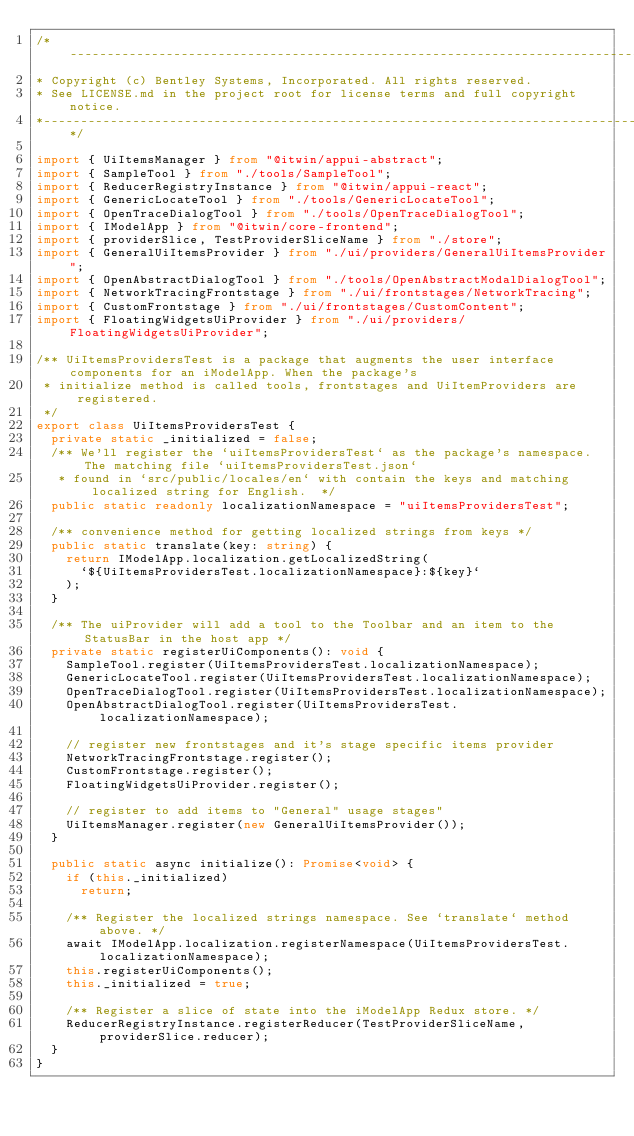<code> <loc_0><loc_0><loc_500><loc_500><_TypeScript_>/*---------------------------------------------------------------------------------------------
* Copyright (c) Bentley Systems, Incorporated. All rights reserved.
* See LICENSE.md in the project root for license terms and full copyright notice.
*--------------------------------------------------------------------------------------------*/

import { UiItemsManager } from "@itwin/appui-abstract";
import { SampleTool } from "./tools/SampleTool";
import { ReducerRegistryInstance } from "@itwin/appui-react";
import { GenericLocateTool } from "./tools/GenericLocateTool";
import { OpenTraceDialogTool } from "./tools/OpenTraceDialogTool";
import { IModelApp } from "@itwin/core-frontend";
import { providerSlice, TestProviderSliceName } from "./store";
import { GeneralUiItemsProvider } from "./ui/providers/GeneralUiItemsProvider";
import { OpenAbstractDialogTool } from "./tools/OpenAbstractModalDialogTool";
import { NetworkTracingFrontstage } from "./ui/frontstages/NetworkTracing";
import { CustomFrontstage } from "./ui/frontstages/CustomContent";
import { FloatingWidgetsUiProvider } from "./ui/providers/FloatingWidgetsUiProvider";

/** UiItemsProvidersTest is a package that augments the user interface components for an iModelApp. When the package's
 * initialize method is called tools, frontstages and UiItemProviders are registered.
 */
export class UiItemsProvidersTest {
  private static _initialized = false;
  /** We'll register the `uiItemsProvidersTest` as the package's namespace. The matching file `uiItemsProvidersTest.json`
   * found in `src/public/locales/en` with contain the keys and matching localized string for English.  */
  public static readonly localizationNamespace = "uiItemsProvidersTest";

  /** convenience method for getting localized strings from keys */
  public static translate(key: string) {
    return IModelApp.localization.getLocalizedString(
      `${UiItemsProvidersTest.localizationNamespace}:${key}`
    );
  }

  /** The uiProvider will add a tool to the Toolbar and an item to the StatusBar in the host app */
  private static registerUiComponents(): void {
    SampleTool.register(UiItemsProvidersTest.localizationNamespace);
    GenericLocateTool.register(UiItemsProvidersTest.localizationNamespace);
    OpenTraceDialogTool.register(UiItemsProvidersTest.localizationNamespace);
    OpenAbstractDialogTool.register(UiItemsProvidersTest.localizationNamespace);

    // register new frontstages and it's stage specific items provider
    NetworkTracingFrontstage.register();
    CustomFrontstage.register();
    FloatingWidgetsUiProvider.register();

    // register to add items to "General" usage stages"
    UiItemsManager.register(new GeneralUiItemsProvider());
  }

  public static async initialize(): Promise<void> {
    if (this._initialized)
      return;

    /** Register the localized strings namespace. See `translate` method above. */
    await IModelApp.localization.registerNamespace(UiItemsProvidersTest.localizationNamespace);
    this.registerUiComponents();
    this._initialized = true;

    /** Register a slice of state into the iModelApp Redux store. */
    ReducerRegistryInstance.registerReducer(TestProviderSliceName, providerSlice.reducer);
  }
}
</code> 